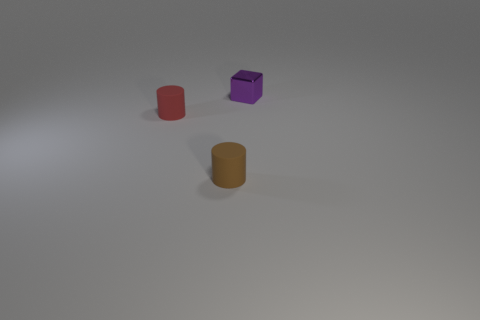Add 3 purple metal spheres. How many objects exist? 6 Subtract all cylinders. How many objects are left? 1 Add 2 tiny purple metal things. How many tiny purple metal things are left? 3 Add 1 cylinders. How many cylinders exist? 3 Subtract 0 cyan cubes. How many objects are left? 3 Subtract all small purple blocks. Subtract all large cyan shiny spheres. How many objects are left? 2 